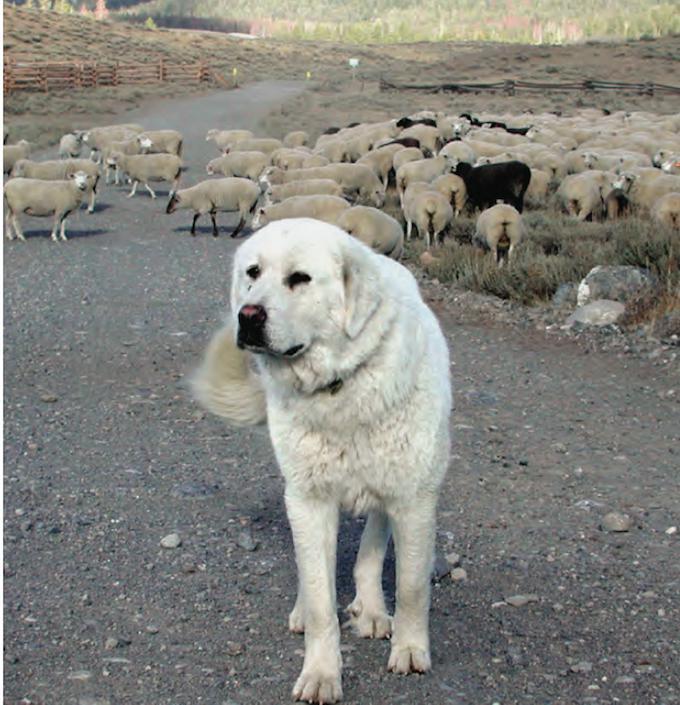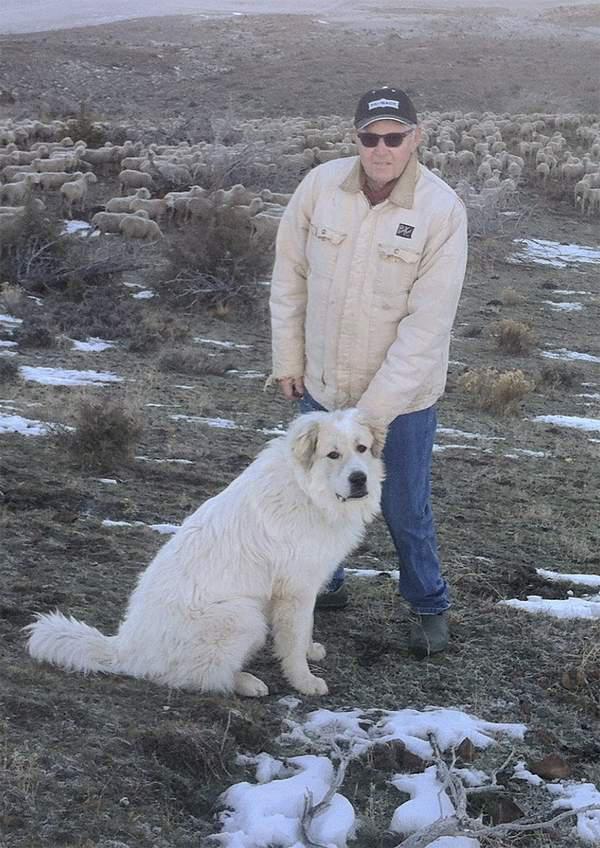The first image is the image on the left, the second image is the image on the right. Evaluate the accuracy of this statement regarding the images: "There is at least one human with the dogs.". Is it true? Answer yes or no. Yes. The first image is the image on the left, the second image is the image on the right. Analyze the images presented: Is the assertion "There is at least 1 white dog and 1 person outside with a herd of sheep in the back." valid? Answer yes or no. Yes. 